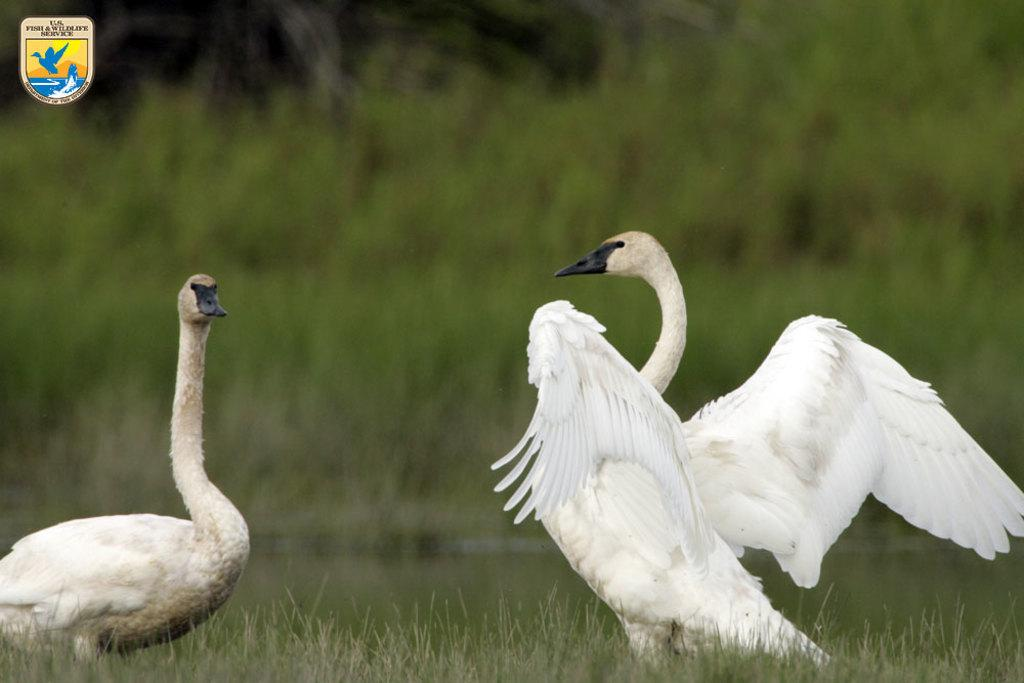What animals are present in the image? There are swans in the image. Where are the swans located? The swans are on the grass. What type of wire is being used by the cats in the image? There are no cats present in the image, so there is no wire being used by them. 